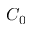Convert formula to latex. <formula><loc_0><loc_0><loc_500><loc_500>C _ { 0 }</formula> 